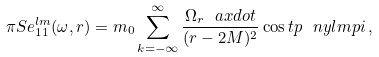Convert formula to latex. <formula><loc_0><loc_0><loc_500><loc_500>\pi S e ^ { l m } _ { 1 1 } ( \omega , r ) = m _ { 0 } \sum _ { k = - \infty } ^ { \infty } \frac { \Omega _ { r } \ a x d o t } { ( r - 2 M ) ^ { 2 } } \cos t p \ n y l m p i \, ,</formula> 